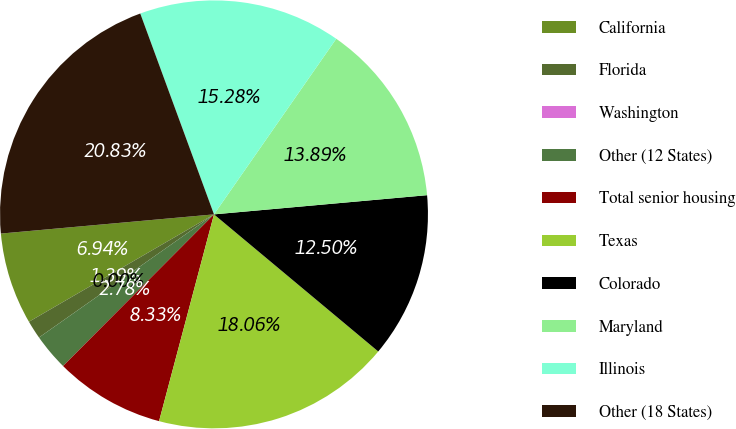<chart> <loc_0><loc_0><loc_500><loc_500><pie_chart><fcel>California<fcel>Florida<fcel>Washington<fcel>Other (12 States)<fcel>Total senior housing<fcel>Texas<fcel>Colorado<fcel>Maryland<fcel>Illinois<fcel>Other (18 States)<nl><fcel>6.94%<fcel>1.39%<fcel>0.0%<fcel>2.78%<fcel>8.33%<fcel>18.06%<fcel>12.5%<fcel>13.89%<fcel>15.28%<fcel>20.83%<nl></chart> 